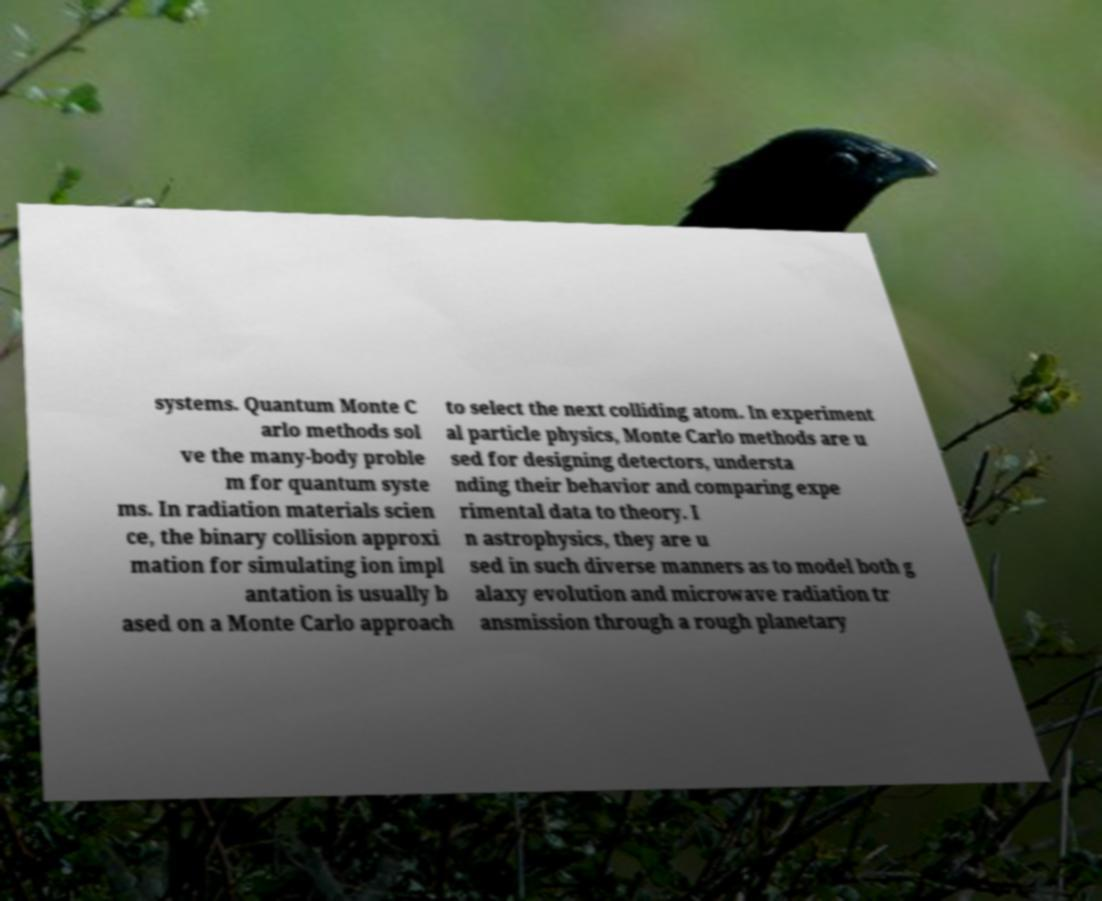Can you read and provide the text displayed in the image?This photo seems to have some interesting text. Can you extract and type it out for me? systems. Quantum Monte C arlo methods sol ve the many-body proble m for quantum syste ms. In radiation materials scien ce, the binary collision approxi mation for simulating ion impl antation is usually b ased on a Monte Carlo approach to select the next colliding atom. In experiment al particle physics, Monte Carlo methods are u sed for designing detectors, understa nding their behavior and comparing expe rimental data to theory. I n astrophysics, they are u sed in such diverse manners as to model both g alaxy evolution and microwave radiation tr ansmission through a rough planetary 